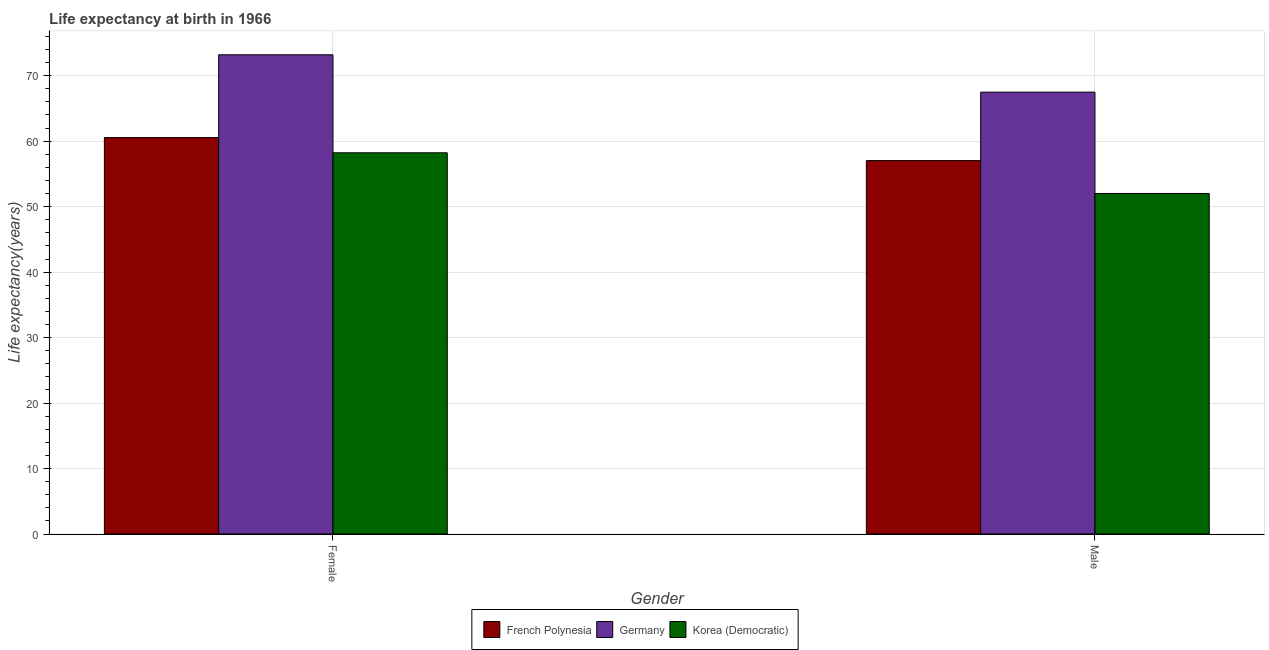Are the number of bars per tick equal to the number of legend labels?
Ensure brevity in your answer.  Yes. How many bars are there on the 2nd tick from the left?
Provide a short and direct response. 3. What is the label of the 2nd group of bars from the left?
Provide a succinct answer. Male. What is the life expectancy(male) in Germany?
Offer a terse response. 67.49. Across all countries, what is the maximum life expectancy(female)?
Provide a succinct answer. 73.19. Across all countries, what is the minimum life expectancy(male)?
Your answer should be compact. 52.01. In which country was the life expectancy(male) maximum?
Give a very brief answer. Germany. In which country was the life expectancy(female) minimum?
Keep it short and to the point. Korea (Democratic). What is the total life expectancy(female) in the graph?
Offer a terse response. 191.96. What is the difference between the life expectancy(male) in French Polynesia and that in Korea (Democratic)?
Your answer should be compact. 5.02. What is the difference between the life expectancy(female) in Korea (Democratic) and the life expectancy(male) in French Polynesia?
Offer a terse response. 1.19. What is the average life expectancy(male) per country?
Keep it short and to the point. 58.84. What is the difference between the life expectancy(female) and life expectancy(male) in Germany?
Give a very brief answer. 5.7. In how many countries, is the life expectancy(female) greater than 42 years?
Provide a short and direct response. 3. What is the ratio of the life expectancy(male) in Korea (Democratic) to that in French Polynesia?
Give a very brief answer. 0.91. Is the life expectancy(female) in Korea (Democratic) less than that in Germany?
Your response must be concise. Yes. In how many countries, is the life expectancy(female) greater than the average life expectancy(female) taken over all countries?
Ensure brevity in your answer.  1. What does the 3rd bar from the left in Male represents?
Your answer should be very brief. Korea (Democratic). What does the 3rd bar from the right in Female represents?
Provide a succinct answer. French Polynesia. How many bars are there?
Ensure brevity in your answer.  6. What is the difference between two consecutive major ticks on the Y-axis?
Your answer should be very brief. 10. Does the graph contain grids?
Keep it short and to the point. Yes. Where does the legend appear in the graph?
Make the answer very short. Bottom center. What is the title of the graph?
Offer a very short reply. Life expectancy at birth in 1966. What is the label or title of the Y-axis?
Ensure brevity in your answer.  Life expectancy(years). What is the Life expectancy(years) in French Polynesia in Female?
Keep it short and to the point. 60.55. What is the Life expectancy(years) in Germany in Female?
Your answer should be very brief. 73.19. What is the Life expectancy(years) of Korea (Democratic) in Female?
Your answer should be very brief. 58.22. What is the Life expectancy(years) in French Polynesia in Male?
Ensure brevity in your answer.  57.03. What is the Life expectancy(years) in Germany in Male?
Provide a succinct answer. 67.49. What is the Life expectancy(years) in Korea (Democratic) in Male?
Offer a terse response. 52.01. Across all Gender, what is the maximum Life expectancy(years) in French Polynesia?
Your answer should be very brief. 60.55. Across all Gender, what is the maximum Life expectancy(years) of Germany?
Your answer should be very brief. 73.19. Across all Gender, what is the maximum Life expectancy(years) of Korea (Democratic)?
Offer a very short reply. 58.22. Across all Gender, what is the minimum Life expectancy(years) of French Polynesia?
Give a very brief answer. 57.03. Across all Gender, what is the minimum Life expectancy(years) in Germany?
Your answer should be compact. 67.49. Across all Gender, what is the minimum Life expectancy(years) of Korea (Democratic)?
Ensure brevity in your answer.  52.01. What is the total Life expectancy(years) of French Polynesia in the graph?
Your answer should be very brief. 117.58. What is the total Life expectancy(years) of Germany in the graph?
Give a very brief answer. 140.68. What is the total Life expectancy(years) of Korea (Democratic) in the graph?
Offer a terse response. 110.23. What is the difference between the Life expectancy(years) of French Polynesia in Female and that in Male?
Provide a short and direct response. 3.52. What is the difference between the Life expectancy(years) of Germany in Female and that in Male?
Keep it short and to the point. 5.71. What is the difference between the Life expectancy(years) in Korea (Democratic) in Female and that in Male?
Provide a succinct answer. 6.21. What is the difference between the Life expectancy(years) in French Polynesia in Female and the Life expectancy(years) in Germany in Male?
Your answer should be compact. -6.94. What is the difference between the Life expectancy(years) of French Polynesia in Female and the Life expectancy(years) of Korea (Democratic) in Male?
Offer a very short reply. 8.54. What is the difference between the Life expectancy(years) of Germany in Female and the Life expectancy(years) of Korea (Democratic) in Male?
Make the answer very short. 21.18. What is the average Life expectancy(years) in French Polynesia per Gender?
Provide a succinct answer. 58.79. What is the average Life expectancy(years) of Germany per Gender?
Offer a terse response. 70.34. What is the average Life expectancy(years) of Korea (Democratic) per Gender?
Offer a terse response. 55.12. What is the difference between the Life expectancy(years) of French Polynesia and Life expectancy(years) of Germany in Female?
Your answer should be very brief. -12.65. What is the difference between the Life expectancy(years) in French Polynesia and Life expectancy(years) in Korea (Democratic) in Female?
Provide a succinct answer. 2.32. What is the difference between the Life expectancy(years) of Germany and Life expectancy(years) of Korea (Democratic) in Female?
Make the answer very short. 14.97. What is the difference between the Life expectancy(years) in French Polynesia and Life expectancy(years) in Germany in Male?
Your response must be concise. -10.46. What is the difference between the Life expectancy(years) in French Polynesia and Life expectancy(years) in Korea (Democratic) in Male?
Make the answer very short. 5.02. What is the difference between the Life expectancy(years) of Germany and Life expectancy(years) of Korea (Democratic) in Male?
Provide a short and direct response. 15.48. What is the ratio of the Life expectancy(years) in French Polynesia in Female to that in Male?
Your answer should be very brief. 1.06. What is the ratio of the Life expectancy(years) in Germany in Female to that in Male?
Provide a short and direct response. 1.08. What is the ratio of the Life expectancy(years) in Korea (Democratic) in Female to that in Male?
Your answer should be compact. 1.12. What is the difference between the highest and the second highest Life expectancy(years) of French Polynesia?
Make the answer very short. 3.52. What is the difference between the highest and the second highest Life expectancy(years) of Germany?
Your response must be concise. 5.71. What is the difference between the highest and the second highest Life expectancy(years) of Korea (Democratic)?
Offer a very short reply. 6.21. What is the difference between the highest and the lowest Life expectancy(years) in French Polynesia?
Make the answer very short. 3.52. What is the difference between the highest and the lowest Life expectancy(years) of Germany?
Ensure brevity in your answer.  5.71. What is the difference between the highest and the lowest Life expectancy(years) of Korea (Democratic)?
Your response must be concise. 6.21. 